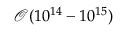Convert formula to latex. <formula><loc_0><loc_0><loc_500><loc_500>\mathcal { O } ( 1 0 ^ { 1 4 } - 1 0 ^ { 1 5 } )</formula> 